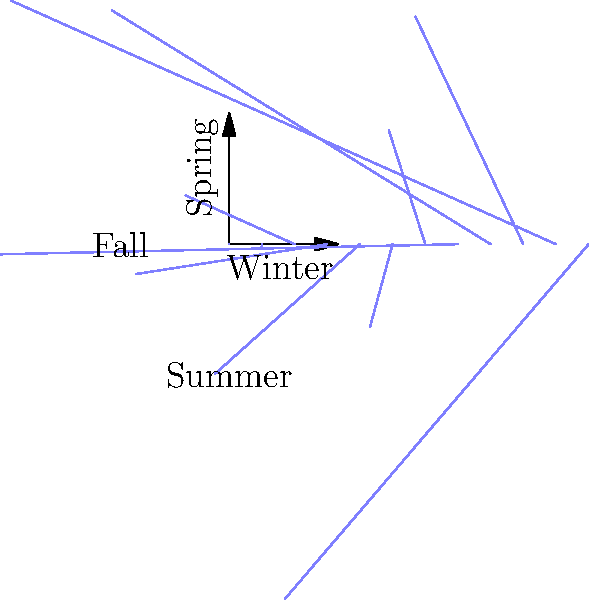As a homeowner hosting travelers, you've recorded the number of guests throughout the year. The polar rose diagram represents this data, with each petal's length indicating the number of travelers for that month. Which season shows the highest influx of travelers, and approximately how many guests did you host during its peak month? To answer this question, we need to analyze the polar rose diagram:

1. The diagram is divided into four quadrants, representing the four seasons:
   - Top right: Spring
   - Bottom right: Summer
   - Bottom left: Fall
   - Top left: Winter

2. Each petal represents a month, and its length indicates the number of travelers.

3. Examining the diagram:
   - Winter (top left) has the shortest petals.
   - Spring (top right) has medium-length petals.
   - Summer (bottom right) has the longest petals.
   - Fall (bottom left) has petals that decrease in length.

4. The summer quadrant clearly shows the highest influx of travelers.

5. In the summer quadrant, the longest petal represents the peak month.

6. Estimating the length of the longest petal, it extends to about 120 units on the scale.

Therefore, summer shows the highest influx of travelers, with approximately 120 guests during its peak month.
Answer: Summer, 120 guests 